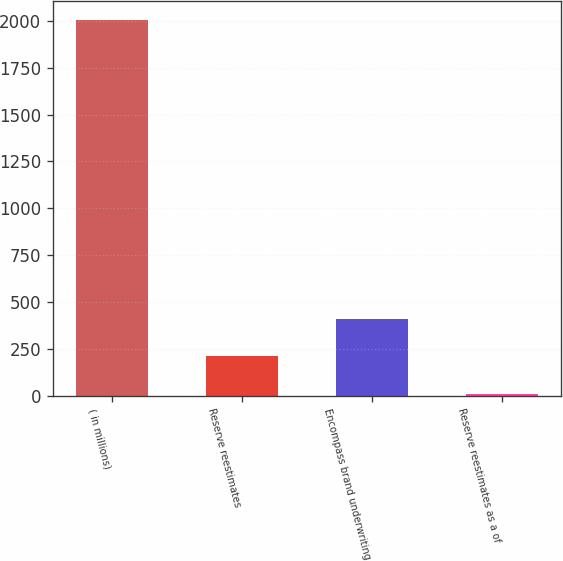<chart> <loc_0><loc_0><loc_500><loc_500><bar_chart><fcel>( in millions)<fcel>Reserve reestimates<fcel>Encompass brand underwriting<fcel>Reserve reestimates as a of<nl><fcel>2006<fcel>209.33<fcel>408.96<fcel>9.7<nl></chart> 